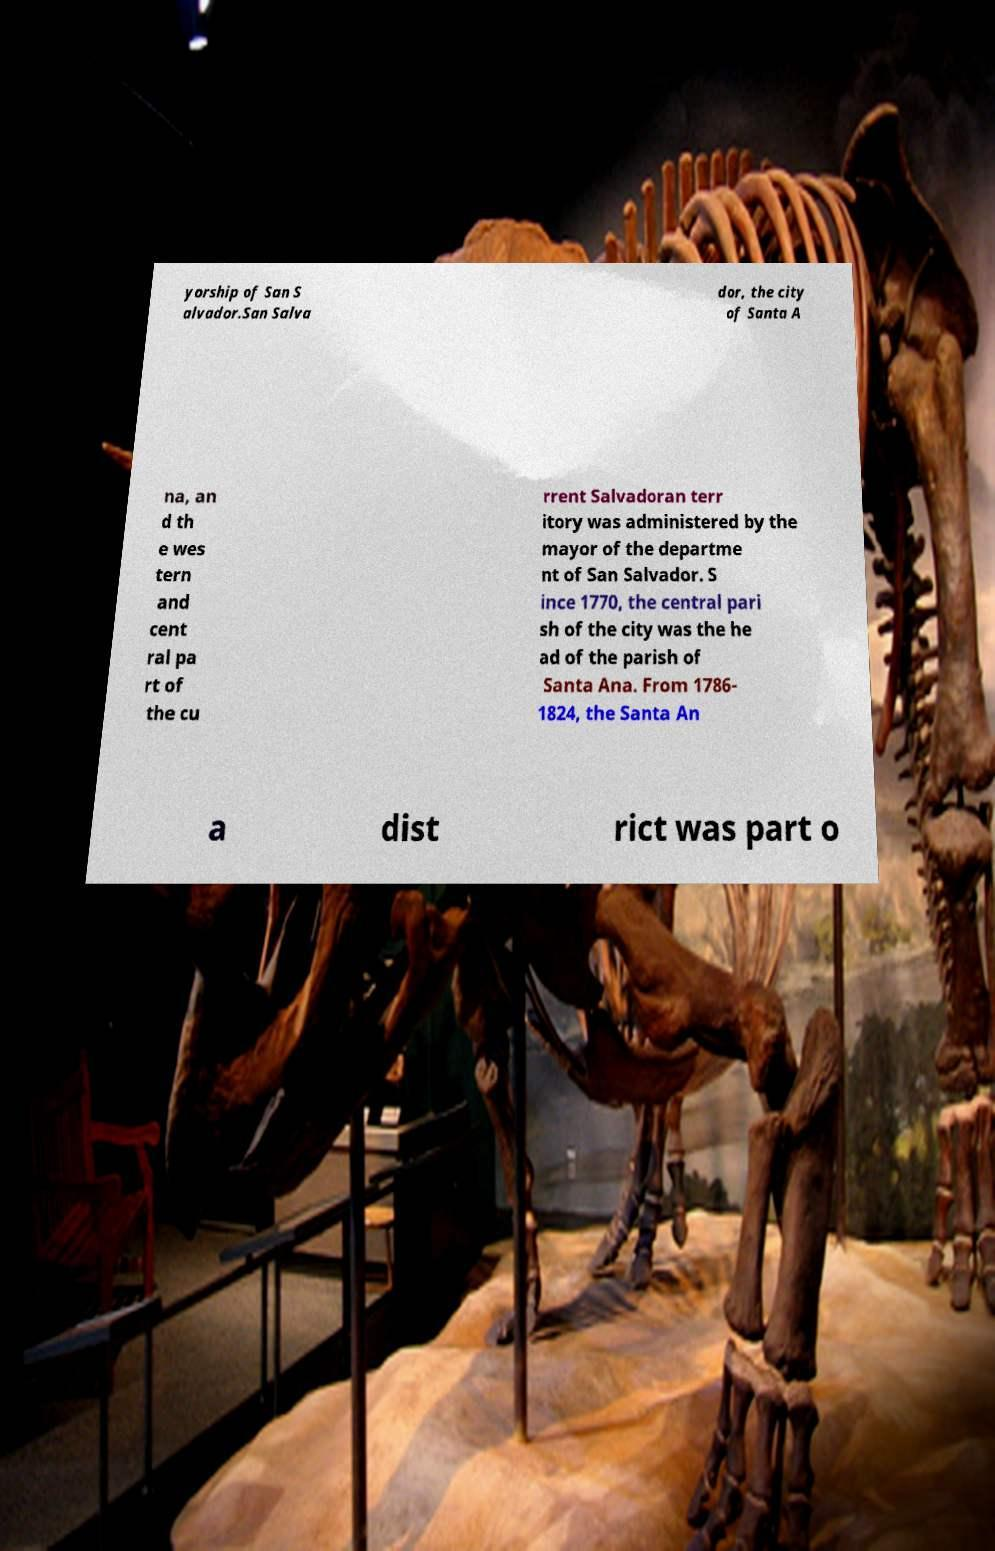Can you accurately transcribe the text from the provided image for me? yorship of San S alvador.San Salva dor, the city of Santa A na, an d th e wes tern and cent ral pa rt of the cu rrent Salvadoran terr itory was administered by the mayor of the departme nt of San Salvador. S ince 1770, the central pari sh of the city was the he ad of the parish of Santa Ana. From 1786- 1824, the Santa An a dist rict was part o 